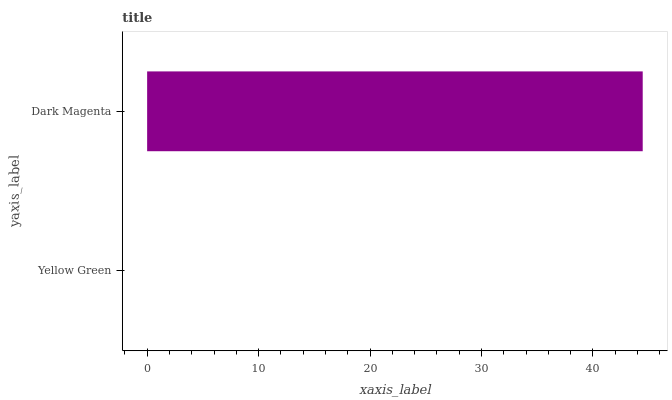Is Yellow Green the minimum?
Answer yes or no. Yes. Is Dark Magenta the maximum?
Answer yes or no. Yes. Is Dark Magenta the minimum?
Answer yes or no. No. Is Dark Magenta greater than Yellow Green?
Answer yes or no. Yes. Is Yellow Green less than Dark Magenta?
Answer yes or no. Yes. Is Yellow Green greater than Dark Magenta?
Answer yes or no. No. Is Dark Magenta less than Yellow Green?
Answer yes or no. No. Is Dark Magenta the high median?
Answer yes or no. Yes. Is Yellow Green the low median?
Answer yes or no. Yes. Is Yellow Green the high median?
Answer yes or no. No. Is Dark Magenta the low median?
Answer yes or no. No. 